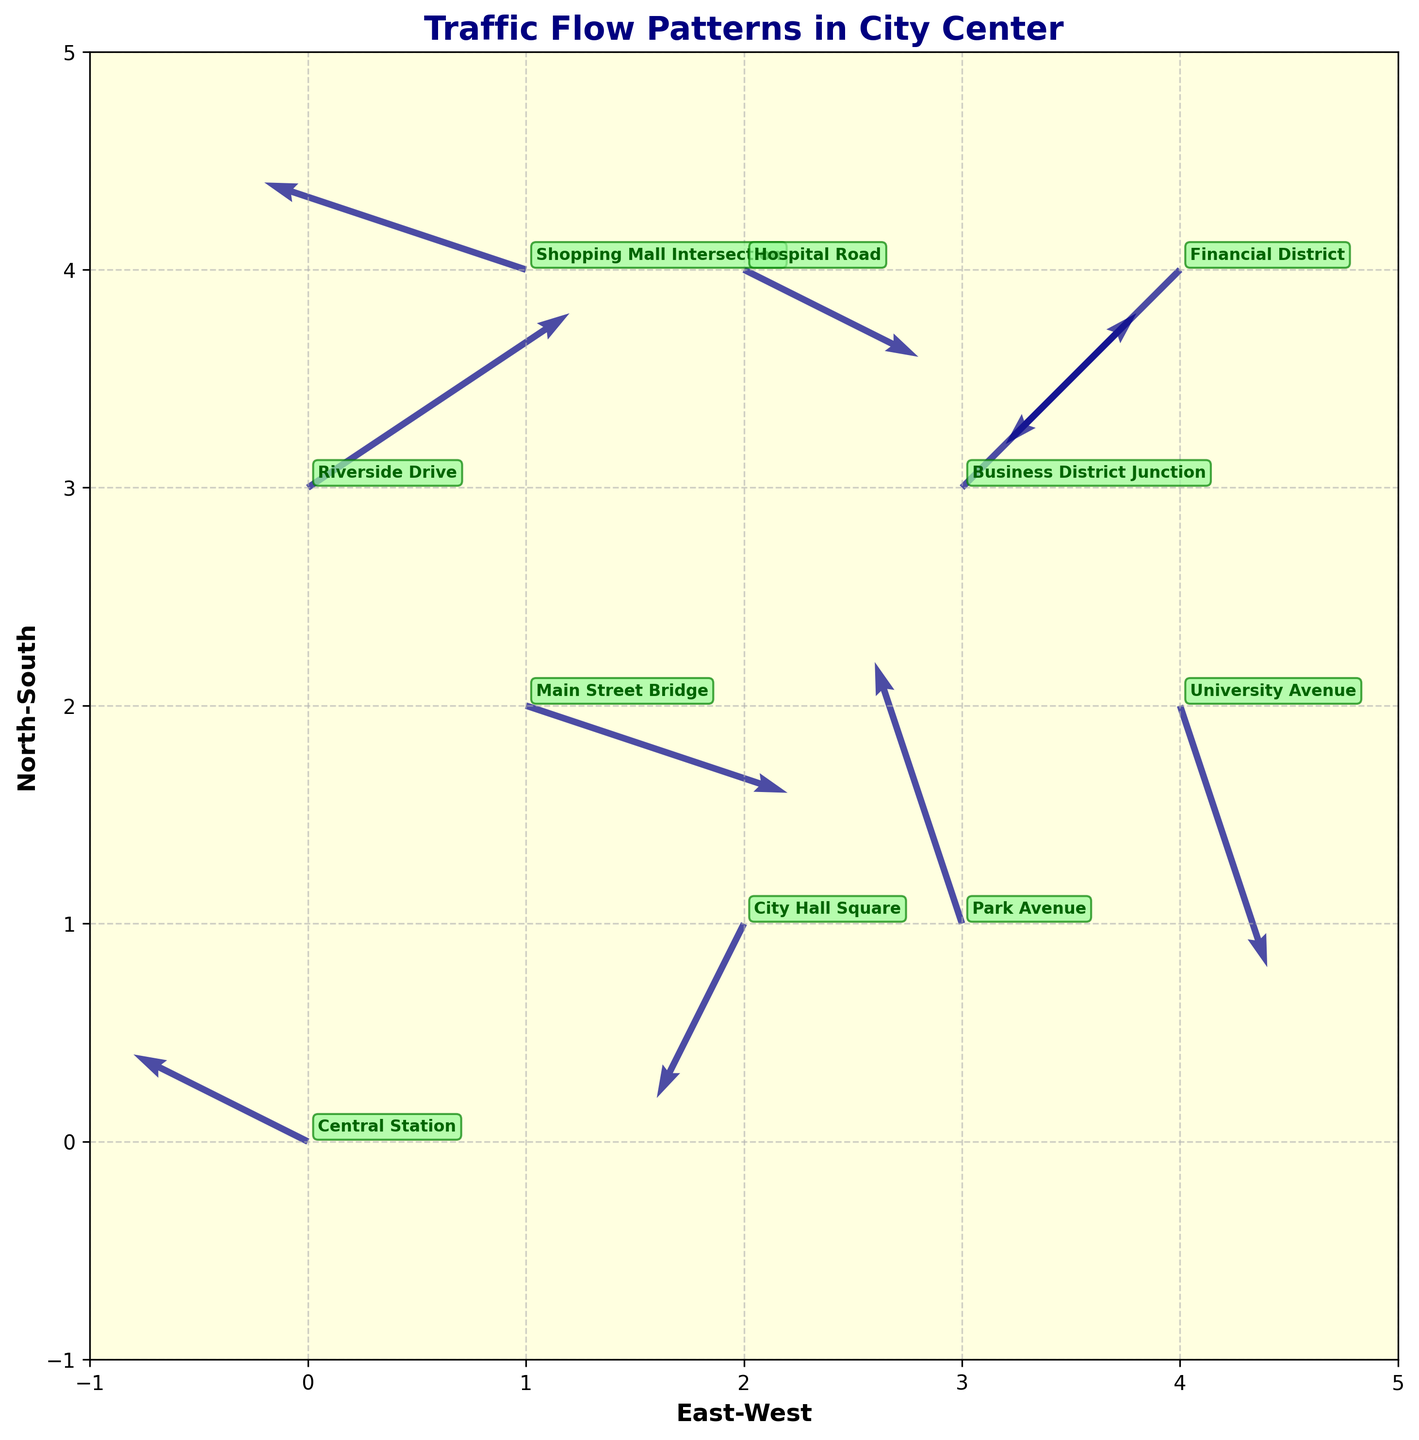Where is the Central Station located in the plot? The Central Station is labeled on the plot, and the (x, y) coordinates associated with it are (0, 0).
Answer: (0, 0) What is the direction of traffic flow at the Financial District? The plot shows the arrow for the Financial District, and it starts at (4, 4) pointing southwest with components (-2, -2).
Answer: Southwest Which location exhibits the highest congestion based on the length of the arrows? The most congested location would have a small or zero resultant vector, indicating little movement. By examining the length of the arrows, Central Station (-2, 1) and City Hall Square (-1, -2) show high congestion.
Answer: Central Station and City Hall Square Between Business District Junction and Shopping Mall Intersection, which has a higher northward traffic component? Compare the vertical components (v) of the arrows. Business District Junction has v = 2, and Shopping Mall Intersection has v = 1.
Answer: Business District Junction Where is traffic predominantly moving westward? Look for arrows with a negative u component. Central Station (u = -2), City Hall Square (u = -1), Shopping Mall Intersection (u = -3), Park Avenue (u = -1), and Financial District (u = -2) all have traffic moving westward.
Answer: Central Station, City Hall Square, Shopping Mall Intersection, Park Avenue, and Financial District What is the direction of traffic flow at Riverside Drive? The arrow for Riverside Drive starts at (0, 3) and points in the direction of (3, 2), indicating a northeast direction.
Answer: Northeast Compare the congestion between Main Street Bridge and University Avenue. Main Street Bridge has a resultant vector of sqrt(3^2 + (-1)^2) = sqrt(10) ≈ 3.16, while University Avenue has sqrt(1^2 + (-3)^2) = sqrt(10) ≈ 3.16. Both have similar congestion levels.
Answer: Similar congestion levels Which location has traffic moving diagonally southwest and what are the vector components? Financial District is moving diagonally southwest with vector components (-2, -2).
Answer: Financial District, (-2, -2) 